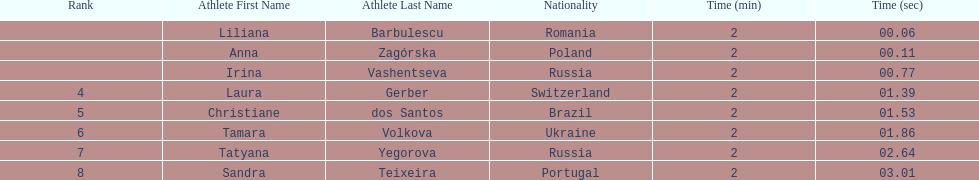Anna zagorska recieved 2nd place, what was her time? 2:00.11. Would you be able to parse every entry in this table? {'header': ['Rank', 'Athlete First Name', 'Athlete Last Name', 'Nationality', 'Time (min)', 'Time (sec)'], 'rows': [['', 'Liliana', 'Barbulescu', 'Romania', '2', '00.06'], ['', 'Anna', 'Zagórska', 'Poland', '2', '00.11'], ['', 'Irina', 'Vashentseva', 'Russia', '2', '00.77'], ['4', 'Laura', 'Gerber', 'Switzerland', '2', '01.39'], ['5', 'Christiane', 'dos Santos', 'Brazil', '2', '01.53'], ['6', 'Tamara', 'Volkova', 'Ukraine', '2', '01.86'], ['7', 'Tatyana', 'Yegorova', 'Russia', '2', '02.64'], ['8', 'Sandra', 'Teixeira', 'Portugal', '2', '03.01']]} 